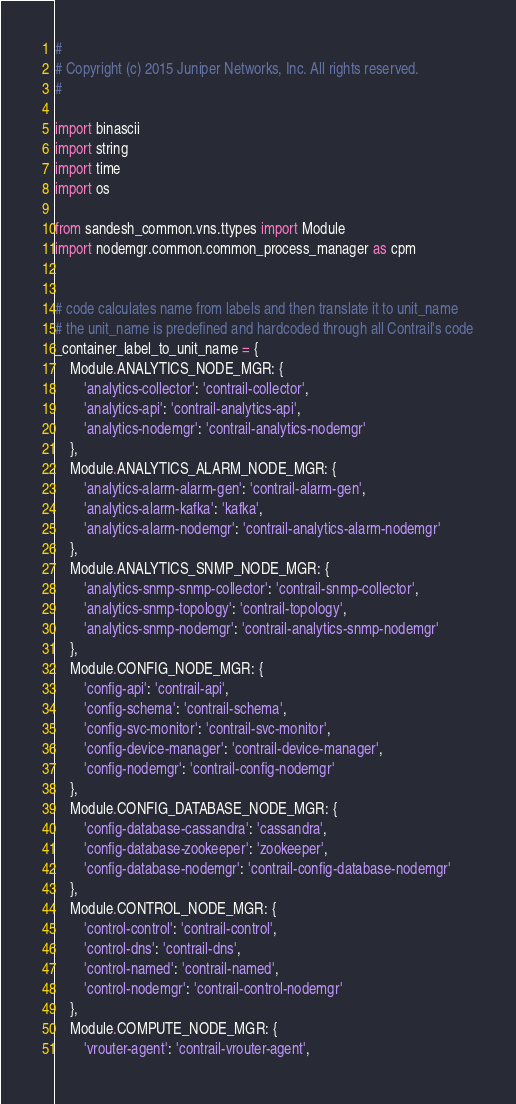<code> <loc_0><loc_0><loc_500><loc_500><_Python_>#
# Copyright (c) 2015 Juniper Networks, Inc. All rights reserved.
#

import binascii
import string
import time
import os

from sandesh_common.vns.ttypes import Module
import nodemgr.common.common_process_manager as cpm


# code calculates name from labels and then translate it to unit_name
# the unit_name is predefined and hardcoded through all Contrail's code
_container_label_to_unit_name = {
    Module.ANALYTICS_NODE_MGR: {
        'analytics-collector': 'contrail-collector',
        'analytics-api': 'contrail-analytics-api',
        'analytics-nodemgr': 'contrail-analytics-nodemgr'
    },
    Module.ANALYTICS_ALARM_NODE_MGR: {
        'analytics-alarm-alarm-gen': 'contrail-alarm-gen',
        'analytics-alarm-kafka': 'kafka',
        'analytics-alarm-nodemgr': 'contrail-analytics-alarm-nodemgr'
    },
    Module.ANALYTICS_SNMP_NODE_MGR: {
        'analytics-snmp-snmp-collector': 'contrail-snmp-collector',
        'analytics-snmp-topology': 'contrail-topology',
        'analytics-snmp-nodemgr': 'contrail-analytics-snmp-nodemgr'
    },
    Module.CONFIG_NODE_MGR: {
        'config-api': 'contrail-api',
        'config-schema': 'contrail-schema',
        'config-svc-monitor': 'contrail-svc-monitor',
        'config-device-manager': 'contrail-device-manager',
        'config-nodemgr': 'contrail-config-nodemgr'
    },
    Module.CONFIG_DATABASE_NODE_MGR: {
        'config-database-cassandra': 'cassandra',
        'config-database-zookeeper': 'zookeeper',
        'config-database-nodemgr': 'contrail-config-database-nodemgr'
    },
    Module.CONTROL_NODE_MGR: {
        'control-control': 'contrail-control',
        'control-dns': 'contrail-dns',
        'control-named': 'contrail-named',
        'control-nodemgr': 'contrail-control-nodemgr'
    },
    Module.COMPUTE_NODE_MGR: {
        'vrouter-agent': 'contrail-vrouter-agent',</code> 